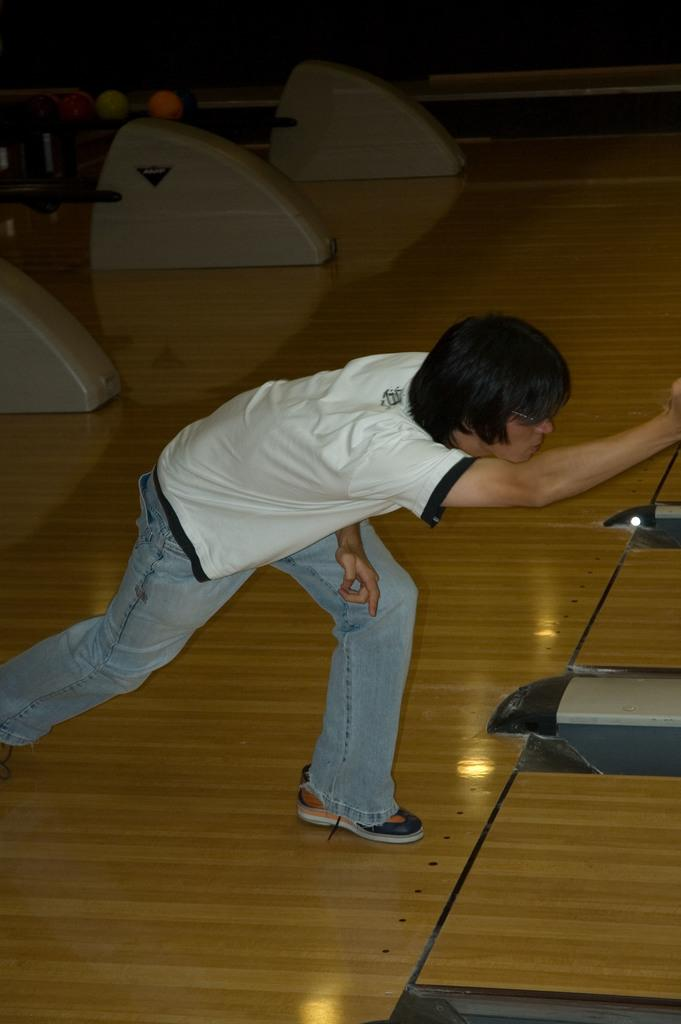Who is the main subject in the image? There is a man in the image. Where is the man located in the image? The man is in the center of the image. What is the man doing in the image? The man is playing a game. What type of pie is the man eating in the image? There is no pie present in the image; the man is playing a game. How many sisters does the man have in the image? There is no information about the man's sisters in the image. 